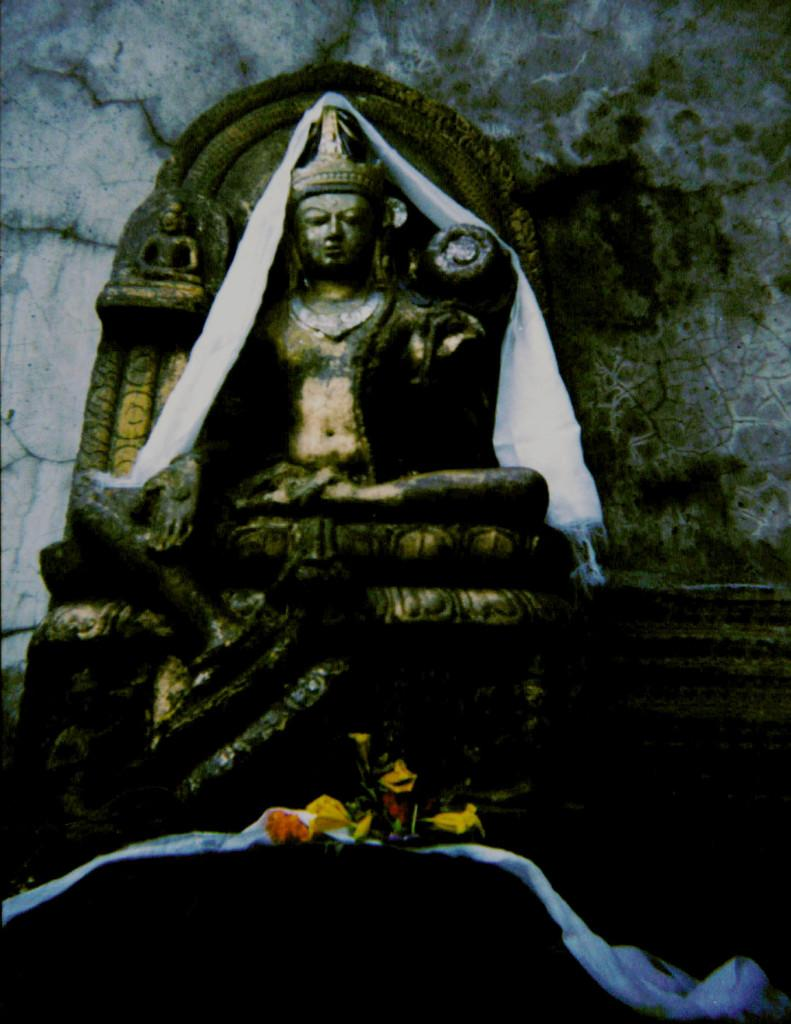What is the main subject of the image? There is a statue of a god in the image. What other objects or elements can be seen in the image? There are flowers and clothes visible in the image. What is in the background of the image? There is a wall in the background of the image. How does the statue increase its rhythm in the image? The statue does not have the ability to increase its rhythm, as it is a stationary object. 